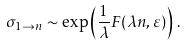Convert formula to latex. <formula><loc_0><loc_0><loc_500><loc_500>\sigma _ { 1 \to n } \sim \exp \left ( \frac { 1 } { \lambda } F ( \lambda n , \varepsilon ) \right ) \, .</formula> 